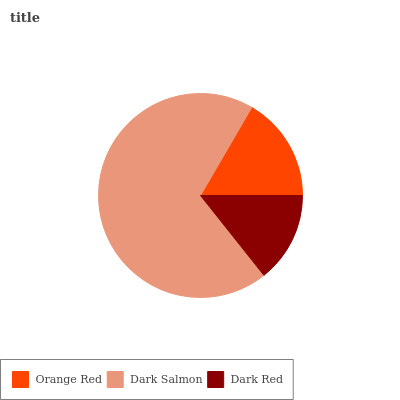Is Dark Red the minimum?
Answer yes or no. Yes. Is Dark Salmon the maximum?
Answer yes or no. Yes. Is Dark Salmon the minimum?
Answer yes or no. No. Is Dark Red the maximum?
Answer yes or no. No. Is Dark Salmon greater than Dark Red?
Answer yes or no. Yes. Is Dark Red less than Dark Salmon?
Answer yes or no. Yes. Is Dark Red greater than Dark Salmon?
Answer yes or no. No. Is Dark Salmon less than Dark Red?
Answer yes or no. No. Is Orange Red the high median?
Answer yes or no. Yes. Is Orange Red the low median?
Answer yes or no. Yes. Is Dark Salmon the high median?
Answer yes or no. No. Is Dark Red the low median?
Answer yes or no. No. 